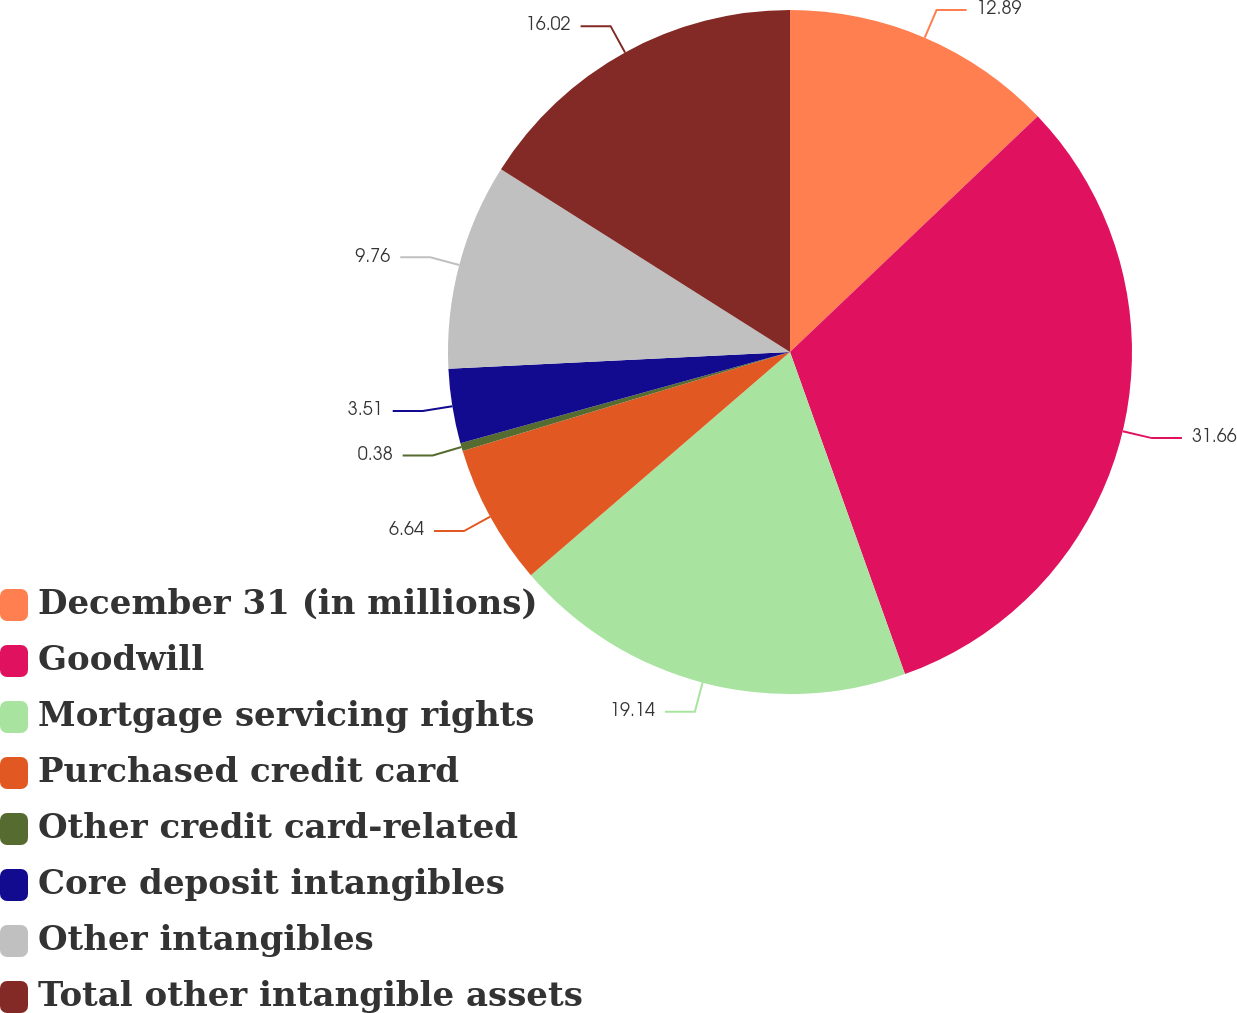Convert chart to OTSL. <chart><loc_0><loc_0><loc_500><loc_500><pie_chart><fcel>December 31 (in millions)<fcel>Goodwill<fcel>Mortgage servicing rights<fcel>Purchased credit card<fcel>Other credit card-related<fcel>Core deposit intangibles<fcel>Other intangibles<fcel>Total other intangible assets<nl><fcel>12.89%<fcel>31.65%<fcel>19.14%<fcel>6.64%<fcel>0.38%<fcel>3.51%<fcel>9.76%<fcel>16.02%<nl></chart> 